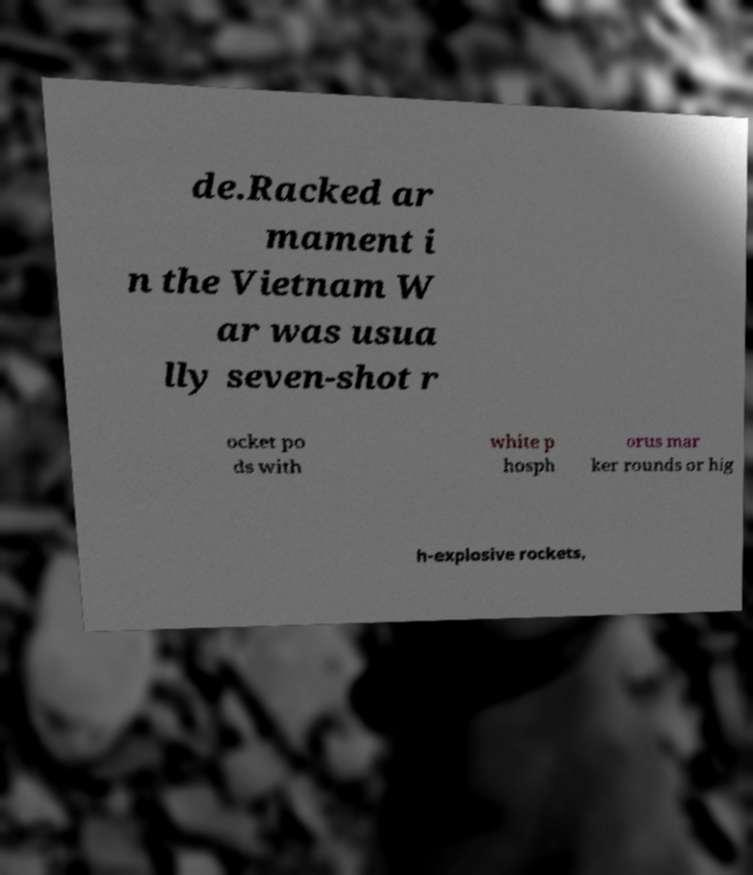Could you assist in decoding the text presented in this image and type it out clearly? de.Racked ar mament i n the Vietnam W ar was usua lly seven-shot r ocket po ds with white p hosph orus mar ker rounds or hig h-explosive rockets, 